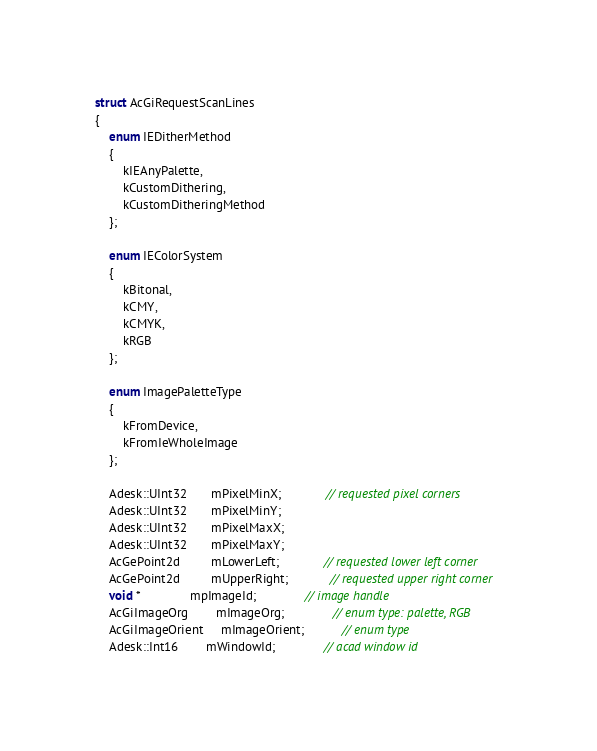<code> <loc_0><loc_0><loc_500><loc_500><_C_>struct AcGiRequestScanLines 
{
    enum IEDitherMethod 
    {
        kIEAnyPalette,
        kCustomDithering,
        kCustomDitheringMethod
    };

    enum IEColorSystem
    {
        kBitonal,
        kCMY,
        kCMYK,
        kRGB
    };

    enum ImagePaletteType
    {
        kFromDevice,
        kFromIeWholeImage
    };

    Adesk::UInt32       mPixelMinX;             // requested pixel corners
    Adesk::UInt32       mPixelMinY;
    Adesk::UInt32       mPixelMaxX;
    Adesk::UInt32       mPixelMaxY;
    AcGePoint2d         mLowerLeft;             // requested lower left corner
    AcGePoint2d         mUpperRight;            // requested upper right corner
    void *              mpImageId;              // image handle
    AcGiImageOrg        mImageOrg;              // enum type: palette, RGB 
    AcGiImageOrient     mImageOrient;           // enum type
    Adesk::Int16        mWindowId;              // acad window id</code> 